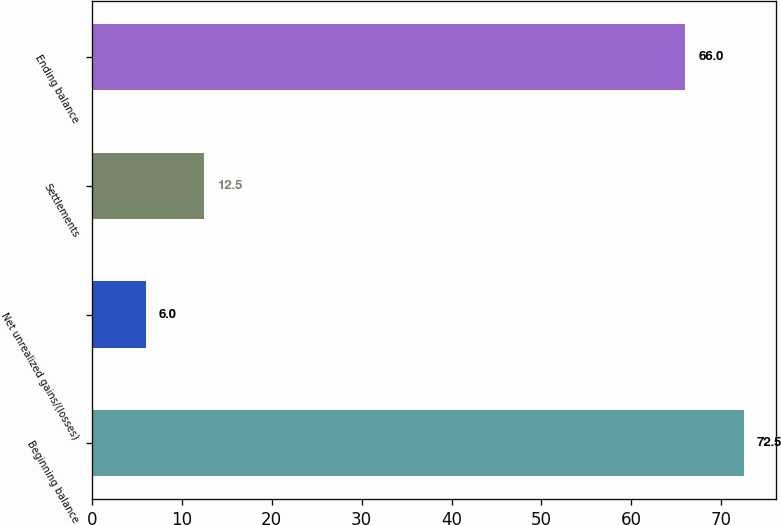Convert chart. <chart><loc_0><loc_0><loc_500><loc_500><bar_chart><fcel>Beginning balance<fcel>Net unrealized gains/(losses)<fcel>Settlements<fcel>Ending balance<nl><fcel>72.5<fcel>6<fcel>12.5<fcel>66<nl></chart> 